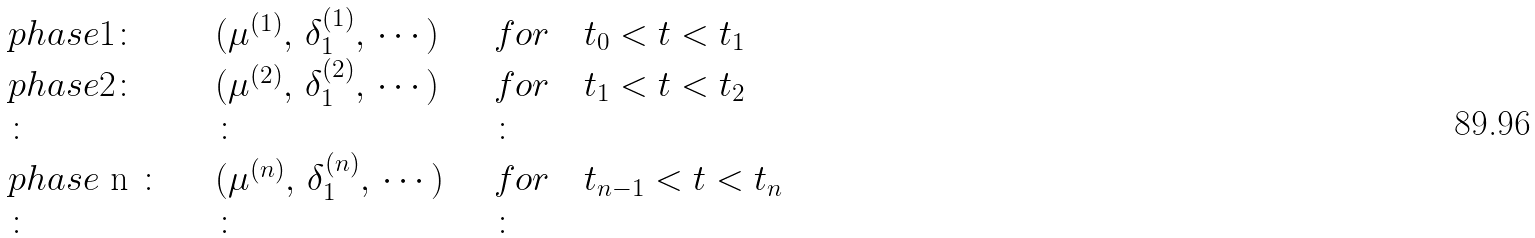Convert formula to latex. <formula><loc_0><loc_0><loc_500><loc_500>\begin{array} { l l l } p h a s e 1 \colon \quad & ( \mu ^ { ( 1 ) } , \, \delta _ { 1 } ^ { ( 1 ) } , \, \cdots \, ) \quad & f o r \quad t _ { 0 } < t < t _ { 1 } \\ p h a s e 2 \colon \quad & ( \mu ^ { ( 2 ) } , \, \delta _ { 1 } ^ { ( 2 ) } , \, \cdots \, ) \quad & f o r \quad t _ { 1 } < t < t _ { 2 } \\ \colon & \colon & \colon \\ p h a s e $ n $ \colon \quad & ( \mu ^ { ( n ) } , \, \delta _ { 1 } ^ { ( n ) } , \, \cdots \, ) \quad & f o r \quad t _ { n - 1 } < t < t _ { n } \\ \colon & \colon & \colon \end{array}</formula> 